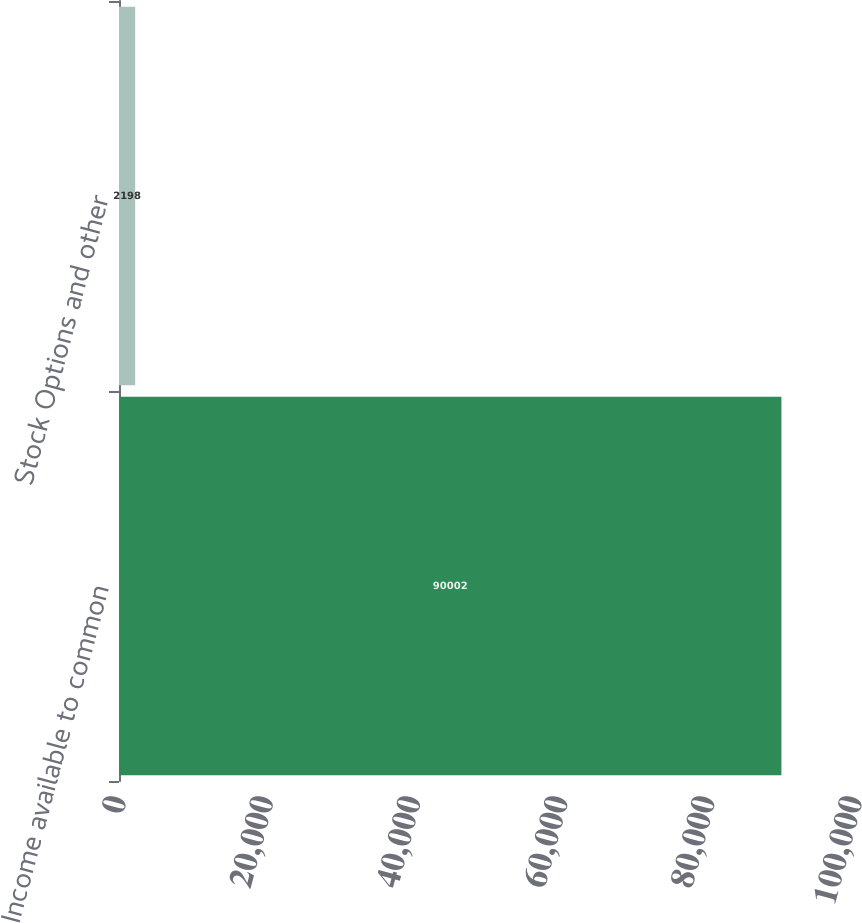<chart> <loc_0><loc_0><loc_500><loc_500><bar_chart><fcel>Income available to common<fcel>Stock Options and other<nl><fcel>90002<fcel>2198<nl></chart> 